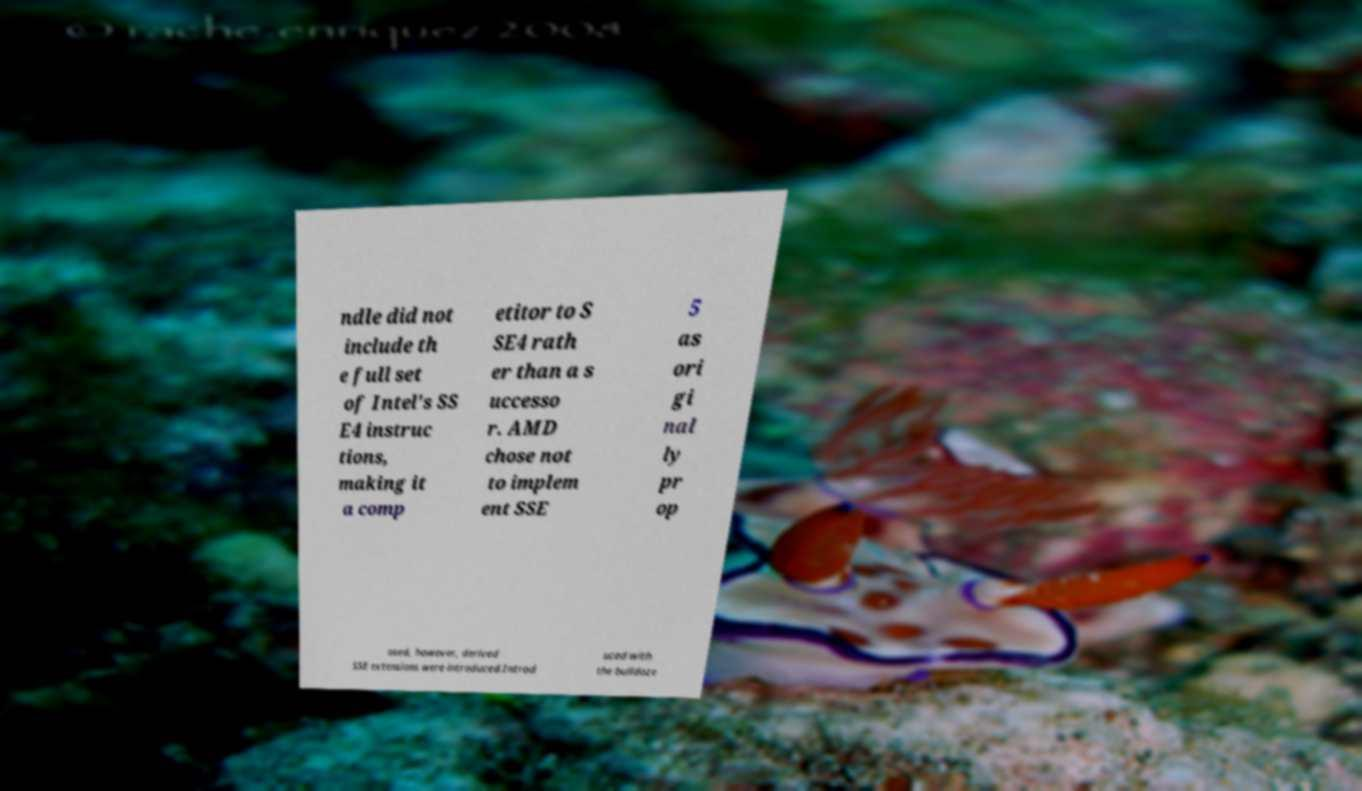Could you extract and type out the text from this image? ndle did not include th e full set of Intel's SS E4 instruc tions, making it a comp etitor to S SE4 rath er than a s uccesso r. AMD chose not to implem ent SSE 5 as ori gi nal ly pr op osed, however, derived SSE extensions were introduced.Introd uced with the bulldoze 